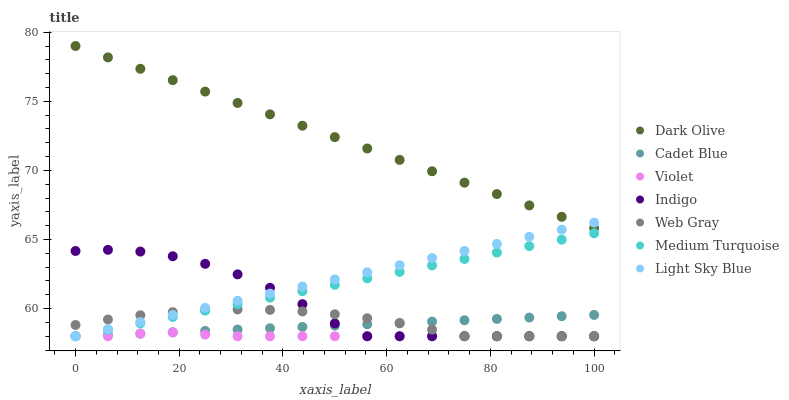Does Violet have the minimum area under the curve?
Answer yes or no. Yes. Does Dark Olive have the maximum area under the curve?
Answer yes or no. Yes. Does Indigo have the minimum area under the curve?
Answer yes or no. No. Does Indigo have the maximum area under the curve?
Answer yes or no. No. Is Light Sky Blue the smoothest?
Answer yes or no. Yes. Is Indigo the roughest?
Answer yes or no. Yes. Is Indigo the smoothest?
Answer yes or no. No. Is Light Sky Blue the roughest?
Answer yes or no. No. Does Cadet Blue have the lowest value?
Answer yes or no. Yes. Does Dark Olive have the lowest value?
Answer yes or no. No. Does Dark Olive have the highest value?
Answer yes or no. Yes. Does Indigo have the highest value?
Answer yes or no. No. Is Violet less than Dark Olive?
Answer yes or no. Yes. Is Dark Olive greater than Cadet Blue?
Answer yes or no. Yes. Does Cadet Blue intersect Web Gray?
Answer yes or no. Yes. Is Cadet Blue less than Web Gray?
Answer yes or no. No. Is Cadet Blue greater than Web Gray?
Answer yes or no. No. Does Violet intersect Dark Olive?
Answer yes or no. No. 